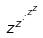<formula> <loc_0><loc_0><loc_500><loc_500>z ^ { z ^ { \cdot ^ { \cdot ^ { z ^ { z } } } } }</formula> 